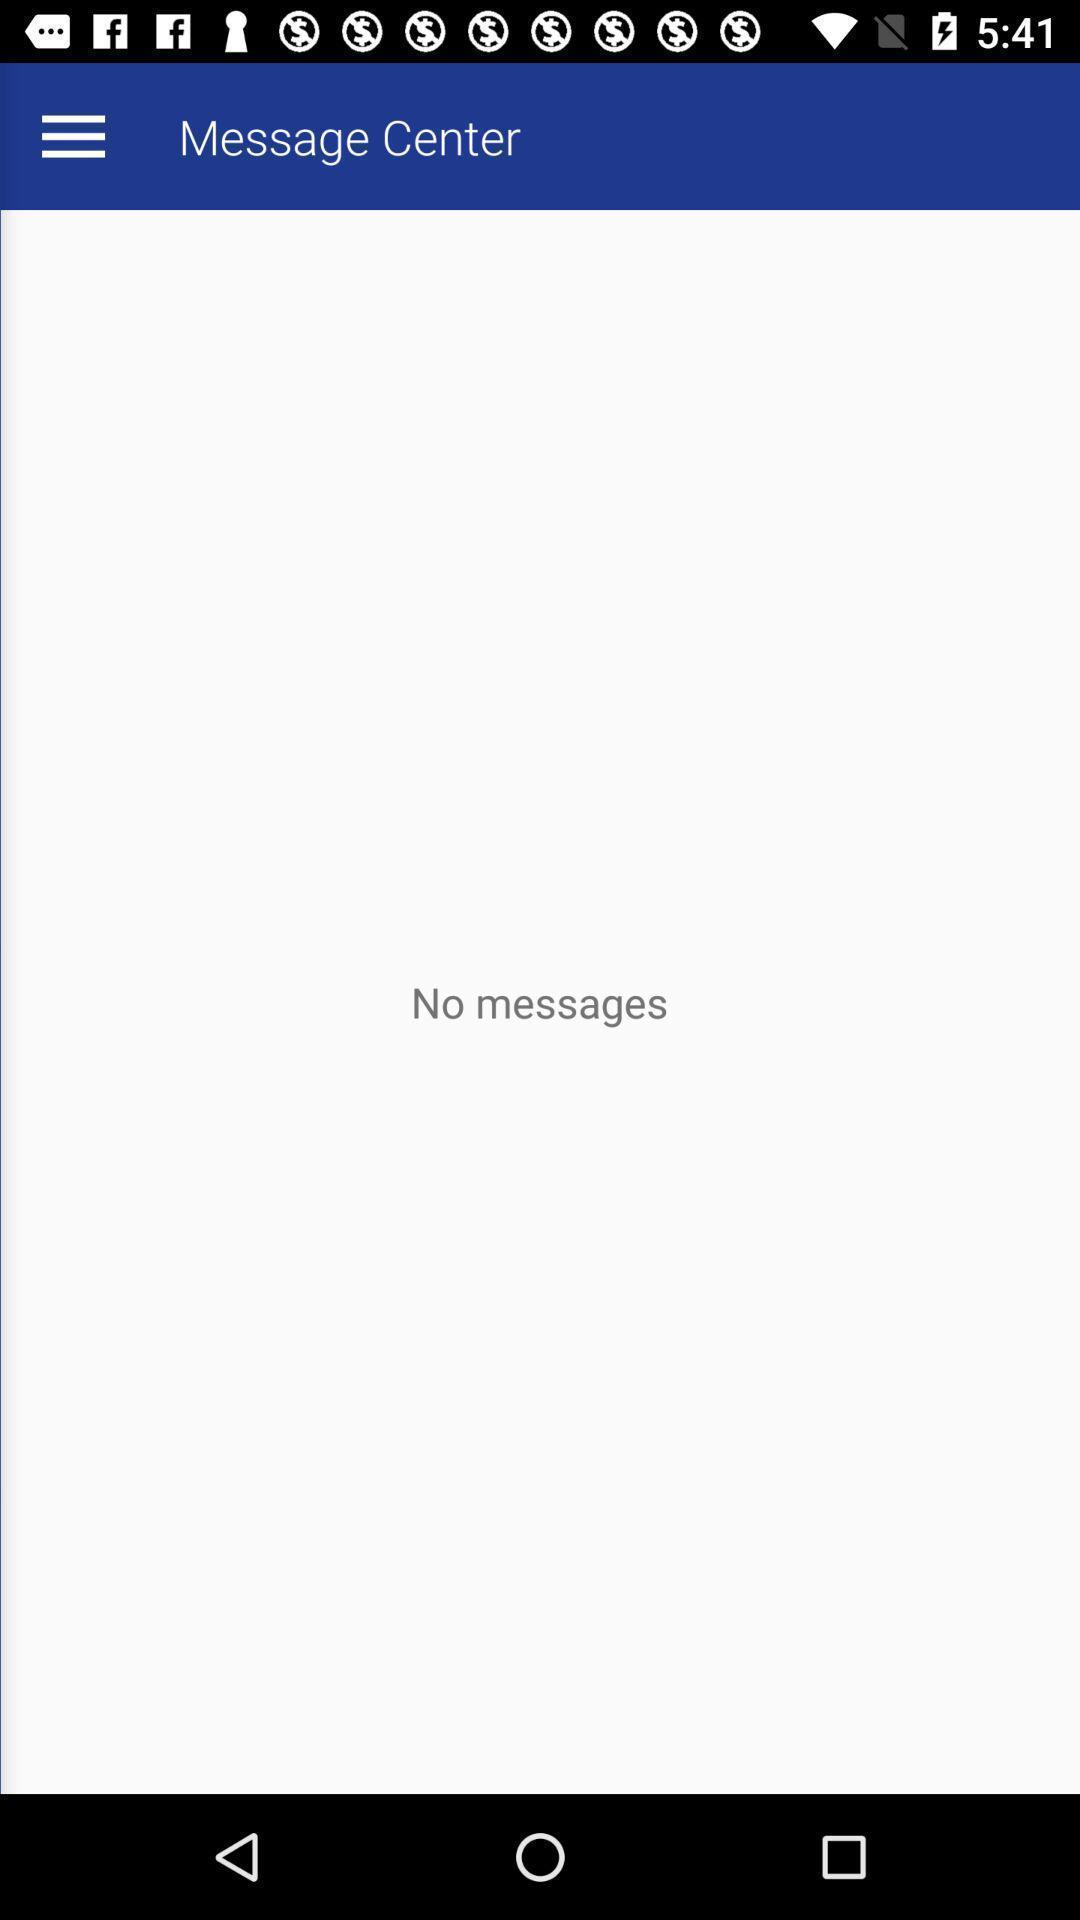Explain what's happening in this screen capture. Page displaying information about messages. 